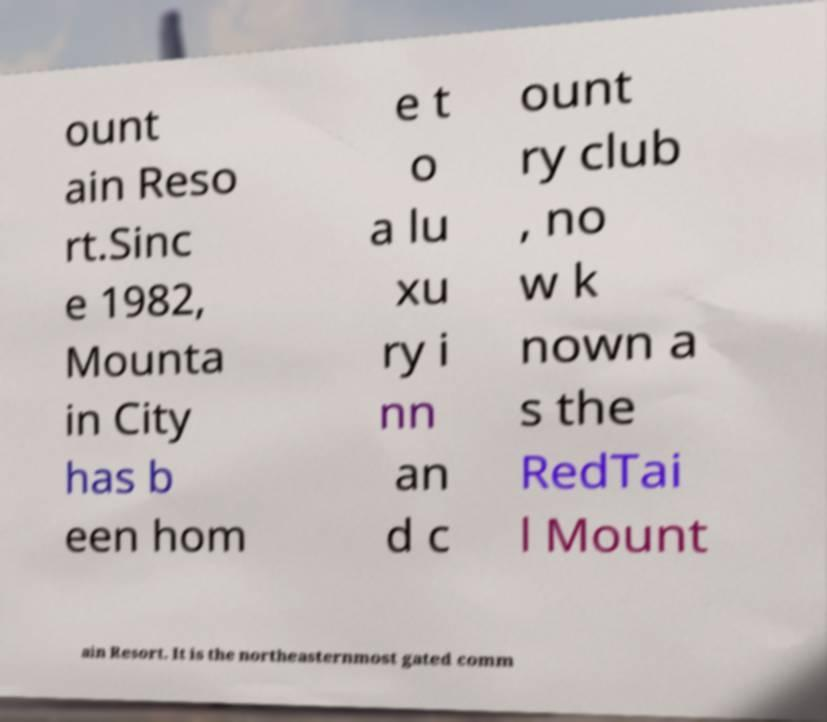I need the written content from this picture converted into text. Can you do that? ount ain Reso rt.Sinc e 1982, Mounta in City has b een hom e t o a lu xu ry i nn an d c ount ry club , no w k nown a s the RedTai l Mount ain Resort. It is the northeasternmost gated comm 